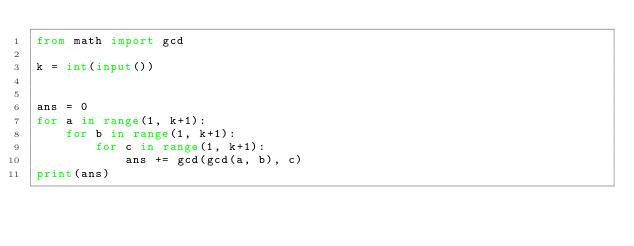Convert code to text. <code><loc_0><loc_0><loc_500><loc_500><_Python_>from math import gcd

k = int(input())


ans = 0
for a in range(1, k+1):
    for b in range(1, k+1):
        for c in range(1, k+1):
            ans += gcd(gcd(a, b), c)
print(ans)</code> 